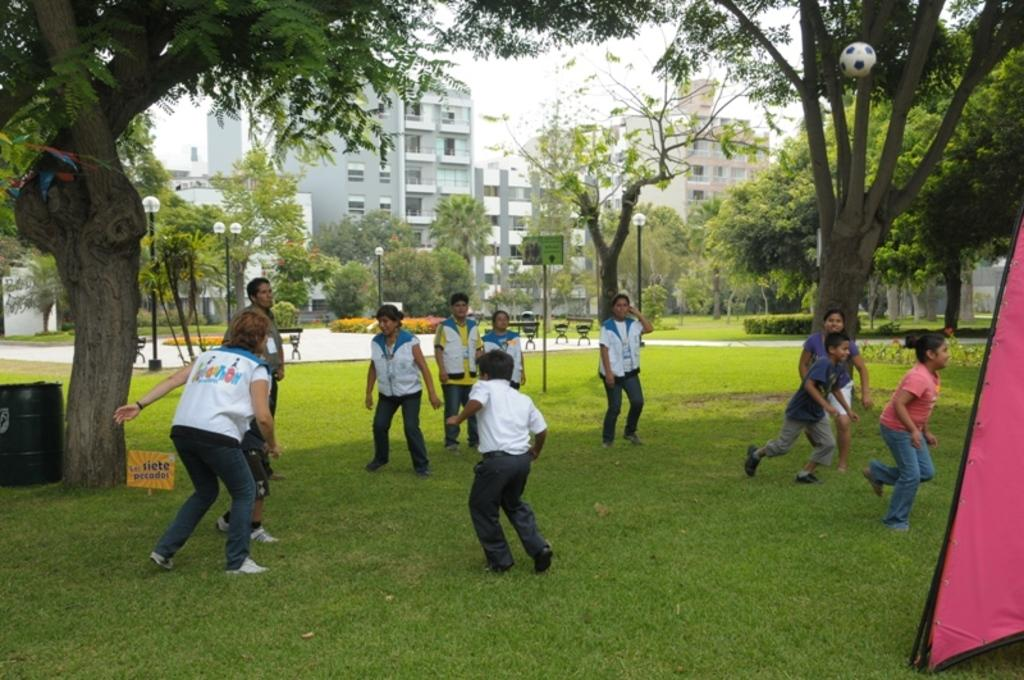What activity are the group of people engaged in? The group of people are playing with a ball. What type of structure can be seen in the image? There is a tent in the image. What type of terrain is visible in the image? Grass is present in the image. What type of material is visible in the image? Boards and poles are visible in the image. What type of lighting is present in the image? Lights are visible in the image. What type of seating is present in the image? Benches are present in the image. What type of vegetation is visible in the image? Trees are visible in the image. What type of man-made structures are visible in the image? Buildings are present in the image. What is visible in the background of the image? The sky is visible in the background of the image. How many bricks can be seen in the image? There are no bricks visible in the image. What type of insects are crawling on the ball in the image? There are no insects visible in the image, let alone crawling on the ball. What type of bird is perched on the tent in the image? There are no birds visible in the image, let alone perched on the tent. 